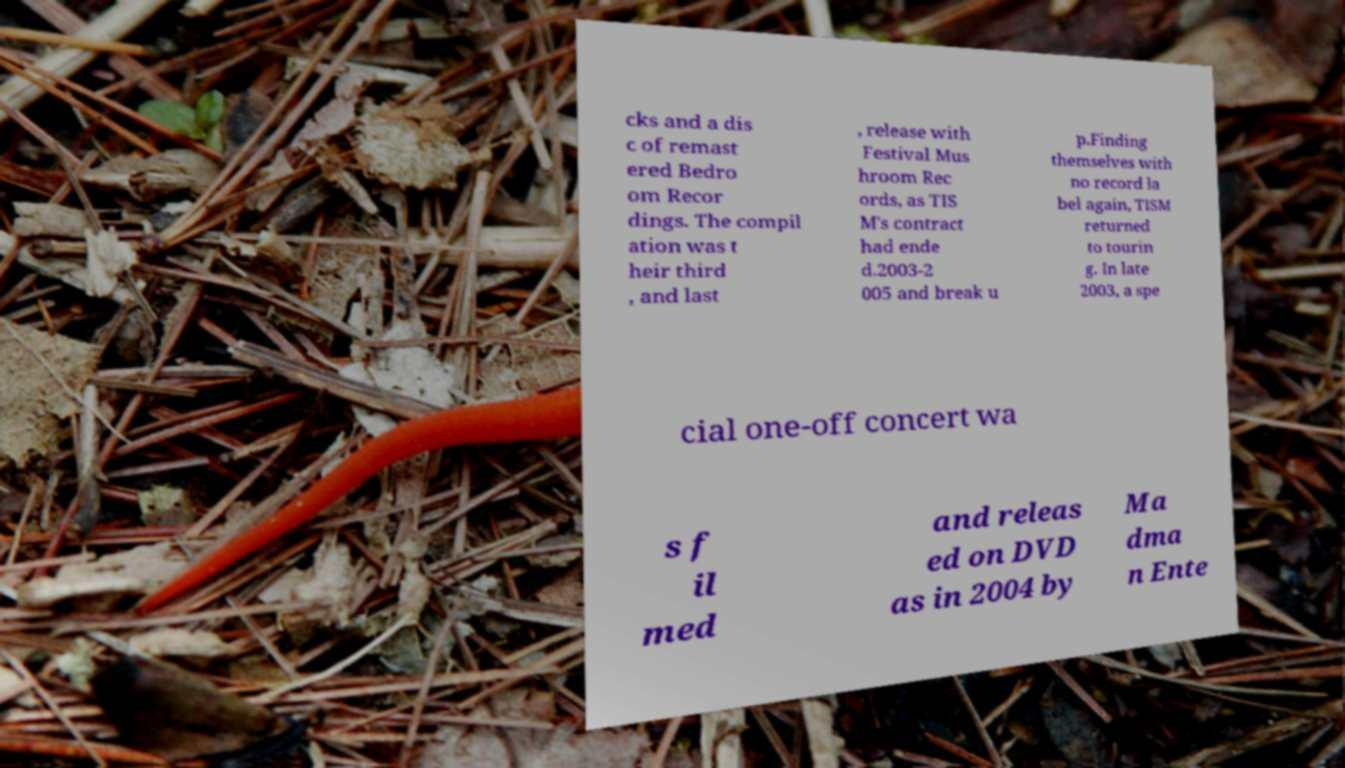For documentation purposes, I need the text within this image transcribed. Could you provide that? cks and a dis c of remast ered Bedro om Recor dings. The compil ation was t heir third , and last , release with Festival Mus hroom Rec ords, as TIS M's contract had ende d.2003-2 005 and break u p.Finding themselves with no record la bel again, TISM returned to tourin g. In late 2003, a spe cial one-off concert wa s f il med and releas ed on DVD as in 2004 by Ma dma n Ente 